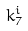Convert formula to latex. <formula><loc_0><loc_0><loc_500><loc_500>k _ { 7 } ^ { i }</formula> 